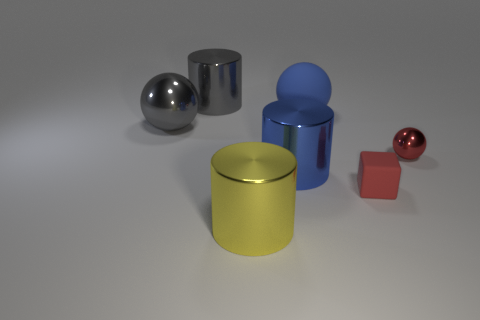Add 3 small blue rubber cylinders. How many objects exist? 10 Subtract all spheres. How many objects are left? 4 Add 5 big gray spheres. How many big gray spheres are left? 6 Add 7 metal balls. How many metal balls exist? 9 Subtract 1 gray balls. How many objects are left? 6 Subtract all blue matte balls. Subtract all tiny red metal things. How many objects are left? 5 